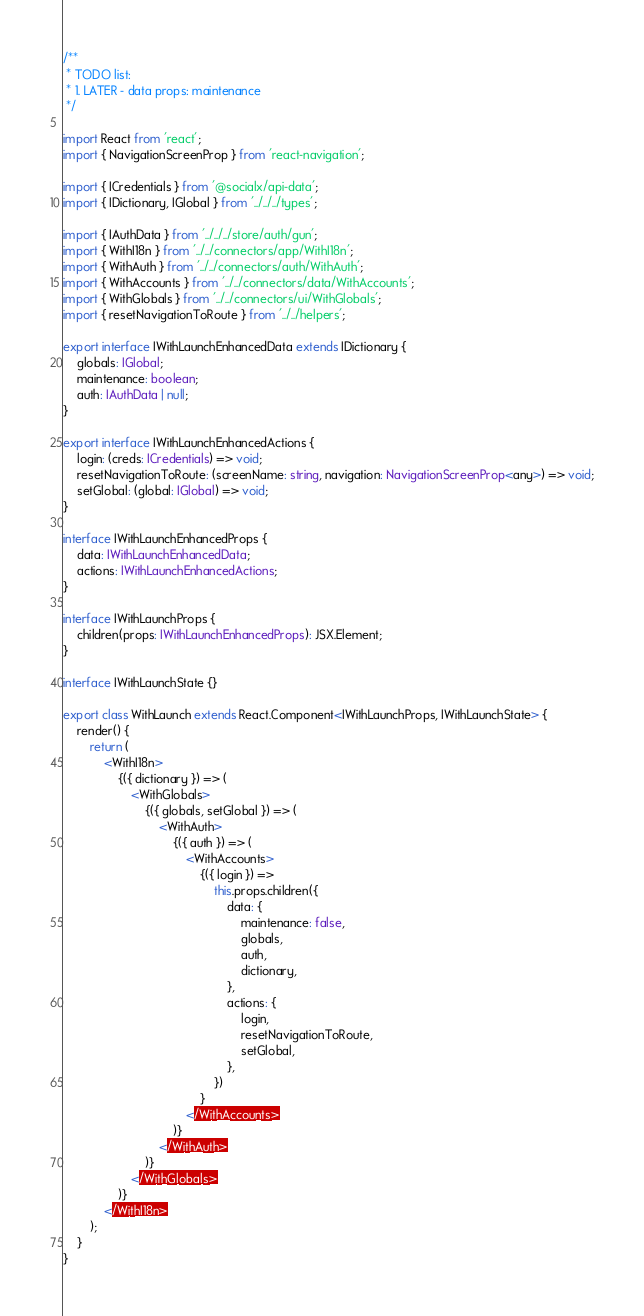Convert code to text. <code><loc_0><loc_0><loc_500><loc_500><_TypeScript_>/**
 * TODO list:
 * 1. LATER - data props: maintenance
 */

import React from 'react';
import { NavigationScreenProp } from 'react-navigation';

import { ICredentials } from '@socialx/api-data';
import { IDictionary, IGlobal } from '../../../types';

import { IAuthData } from '../../../store/auth/gun';
import { WithI18n } from '../../connectors/app/WithI18n';
import { WithAuth } from '../../connectors/auth/WithAuth';
import { WithAccounts } from '../../connectors/data/WithAccounts';
import { WithGlobals } from '../../connectors/ui/WithGlobals';
import { resetNavigationToRoute } from '../../helpers';

export interface IWithLaunchEnhancedData extends IDictionary {
	globals: IGlobal;
	maintenance: boolean;
	auth: IAuthData | null;
}

export interface IWithLaunchEnhancedActions {
	login: (creds: ICredentials) => void;
	resetNavigationToRoute: (screenName: string, navigation: NavigationScreenProp<any>) => void;
	setGlobal: (global: IGlobal) => void;
}

interface IWithLaunchEnhancedProps {
	data: IWithLaunchEnhancedData;
	actions: IWithLaunchEnhancedActions;
}

interface IWithLaunchProps {
	children(props: IWithLaunchEnhancedProps): JSX.Element;
}

interface IWithLaunchState {}

export class WithLaunch extends React.Component<IWithLaunchProps, IWithLaunchState> {
	render() {
		return (
			<WithI18n>
				{({ dictionary }) => (
					<WithGlobals>
						{({ globals, setGlobal }) => (
							<WithAuth>
								{({ auth }) => (
									<WithAccounts>
										{({ login }) =>
											this.props.children({
												data: {
													maintenance: false,
													globals,
													auth,
													dictionary,
												},
												actions: {
													login,
													resetNavigationToRoute,
													setGlobal,
												},
											})
										}
									</WithAccounts>
								)}
							</WithAuth>
						)}
					</WithGlobals>
				)}
			</WithI18n>
		);
	}
}
</code> 